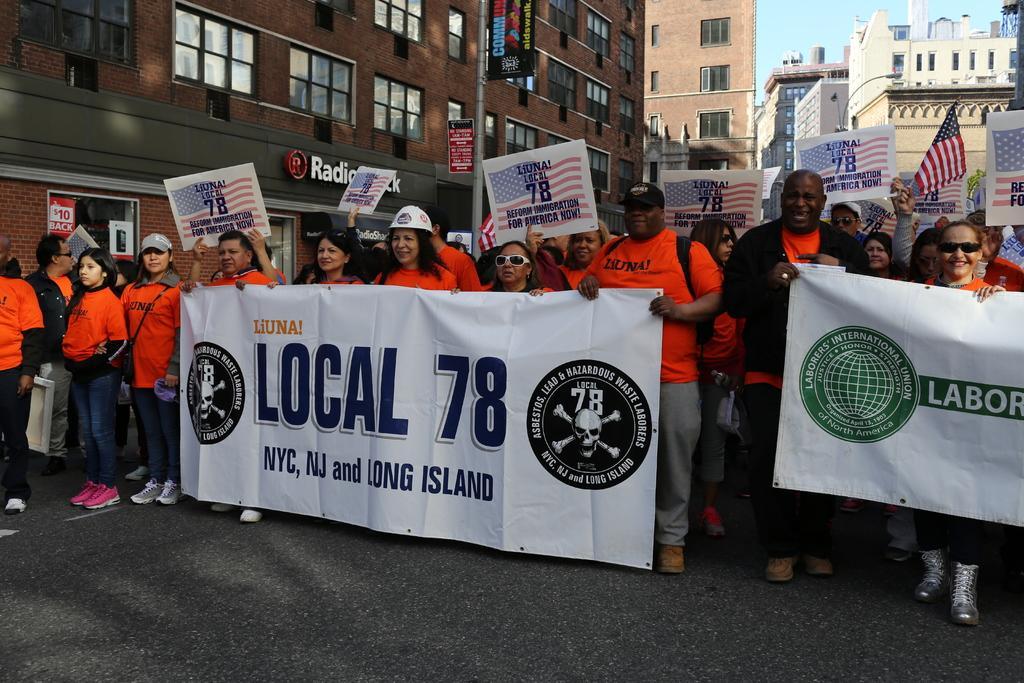Please provide a concise description of this image. In this image, we can see a group of people are standing on the road. Few people are holding banners, boards and few objects. In the background, we can see buildings, walls, glass windows, pole, banners, posters and sky. 